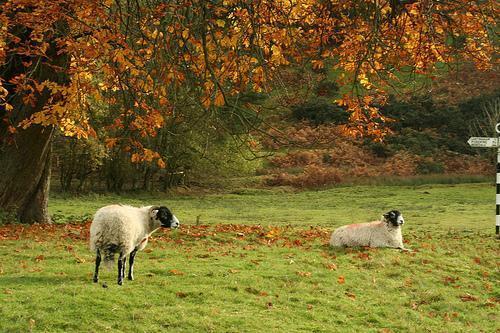How many sheep are there?
Give a very brief answer. 2. How many sheep in the grass?
Give a very brief answer. 2. 